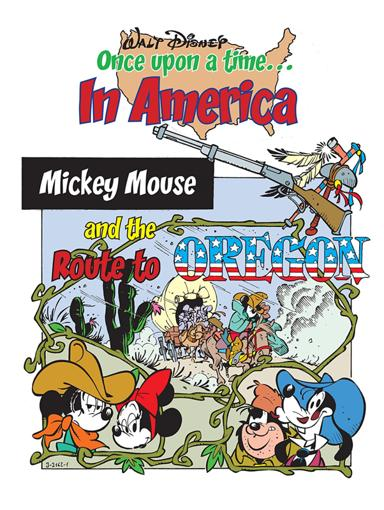What is mentioned in the image related to Disney? The image depicts a colorful poster titled 'Once upon a time in America, Mickey Mouse and the Route to Oregon.' It features iconic Disney characters like Mickey Mouse, Minnie Mouse, and Goofy, engaged in a whimsical depiction of a historical route to Oregon, highlighting Disney's creative take on American history. 